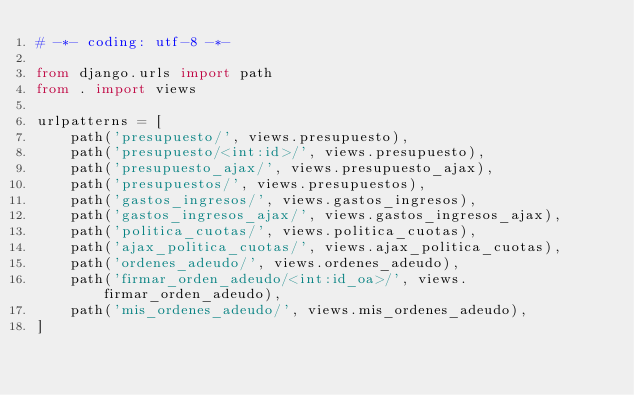Convert code to text. <code><loc_0><loc_0><loc_500><loc_500><_Python_># -*- coding: utf-8 -*-

from django.urls import path
from . import views

urlpatterns = [
    path('presupuesto/', views.presupuesto),
    path('presupuesto/<int:id>/', views.presupuesto),
    path('presupuesto_ajax/', views.presupuesto_ajax),
    path('presupuestos/', views.presupuestos),
    path('gastos_ingresos/', views.gastos_ingresos),
    path('gastos_ingresos_ajax/', views.gastos_ingresos_ajax),
    path('politica_cuotas/', views.politica_cuotas),
    path('ajax_politica_cuotas/', views.ajax_politica_cuotas),
    path('ordenes_adeudo/', views.ordenes_adeudo),
    path('firmar_orden_adeudo/<int:id_oa>/', views.firmar_orden_adeudo),
    path('mis_ordenes_adeudo/', views.mis_ordenes_adeudo),
]</code> 